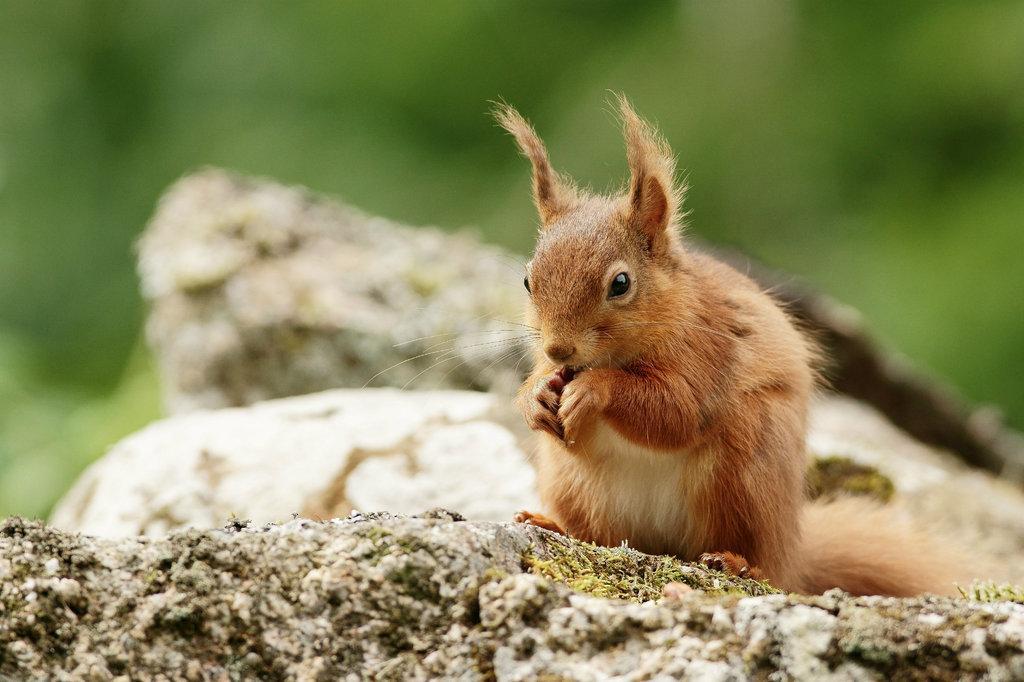Describe this image in one or two sentences. In this image there is a squirrel on the stone. In the background there are two stones one above the other. Behind them it looks blurry. 